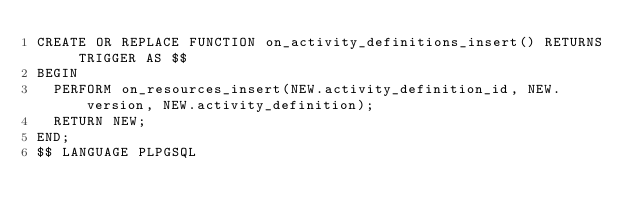<code> <loc_0><loc_0><loc_500><loc_500><_SQL_>CREATE OR REPLACE FUNCTION on_activity_definitions_insert() RETURNS TRIGGER AS $$
BEGIN
	PERFORM on_resources_insert(NEW.activity_definition_id, NEW.version, NEW.activity_definition);
	RETURN NEW;
END;
$$ LANGUAGE PLPGSQL</code> 